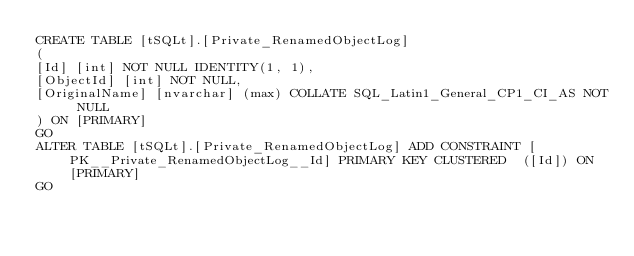<code> <loc_0><loc_0><loc_500><loc_500><_SQL_>CREATE TABLE [tSQLt].[Private_RenamedObjectLog]
(
[Id] [int] NOT NULL IDENTITY(1, 1),
[ObjectId] [int] NOT NULL,
[OriginalName] [nvarchar] (max) COLLATE SQL_Latin1_General_CP1_CI_AS NOT NULL
) ON [PRIMARY]
GO
ALTER TABLE [tSQLt].[Private_RenamedObjectLog] ADD CONSTRAINT [PK__Private_RenamedObjectLog__Id] PRIMARY KEY CLUSTERED  ([Id]) ON [PRIMARY]
GO
</code> 